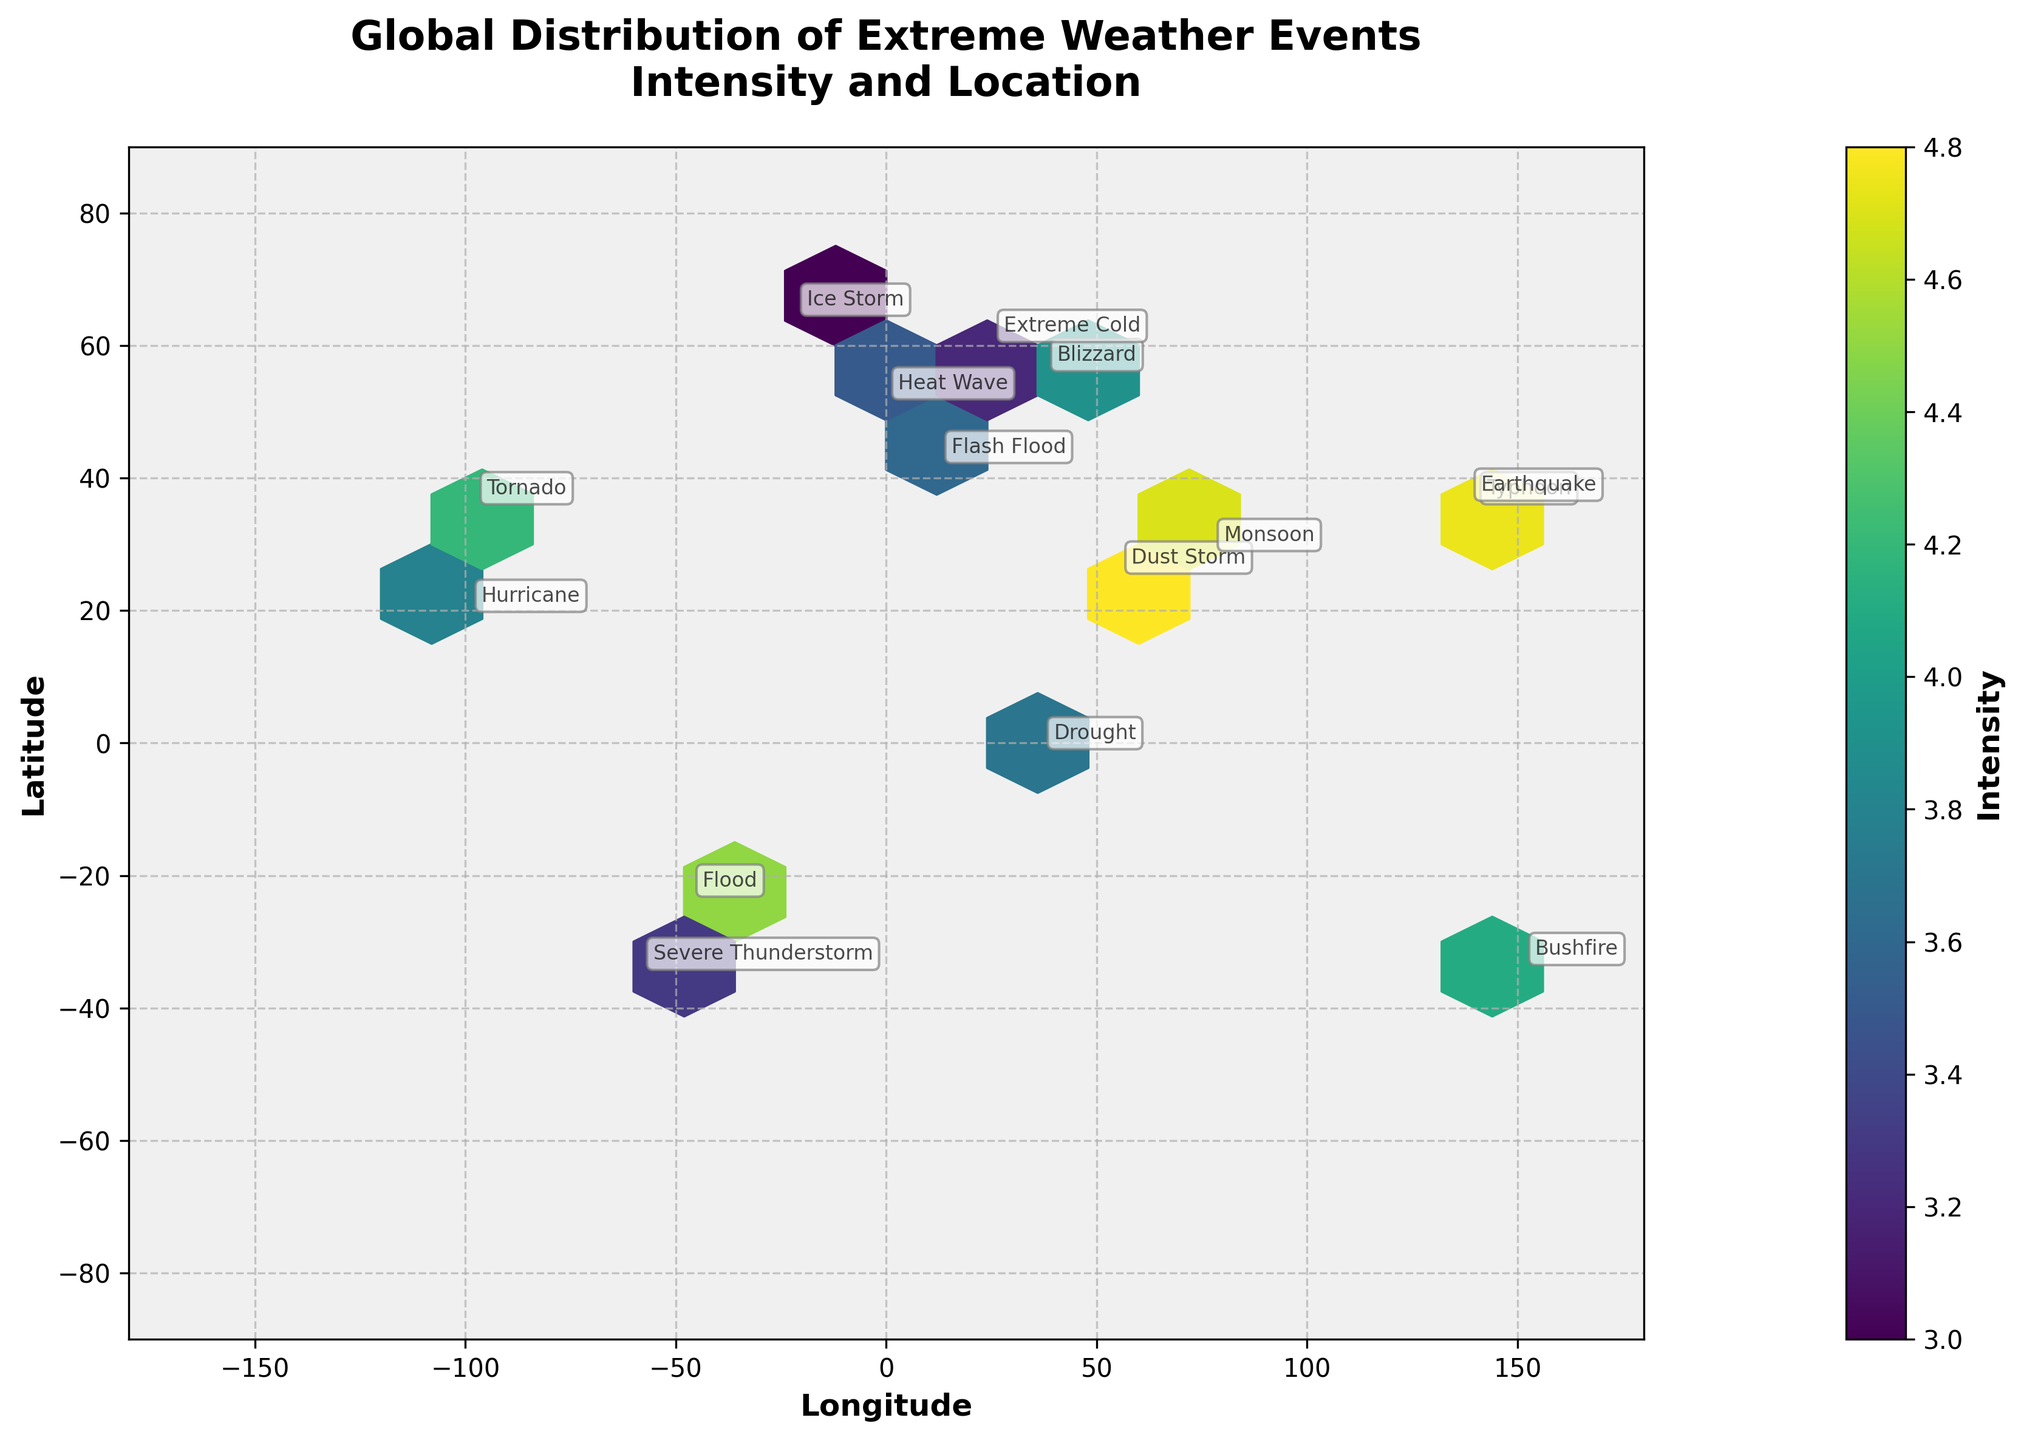What is the title of the figure? The title is displayed at the top center of the figure and is "Global Distribution of Extreme Weather Events\nIntensity and Location".
Answer: "Global Distribution of Extreme Weather Events\nIntensity and Location" What does the color intensity in the hexbin plot represent? The color intensity is explained by the color bar to the right of the plot, labeled "Intensity".
Answer: Intensity What is the range of longitudes shown in the figure? The x-axis, labeled "Longitude", ranges from -180 to 180.
Answer: -180 to 180 Which region shows the highest frequency of extreme weather events according to the annotations? By looking at the text annotations in the plot, South Asia has the highest frequency with an event frequency of 25 for Monsoon.
Answer: South Asia How many grid cells (hexagons) are displayed in the plot? The gridsize of 15 used in the plot generates a honeycomb-like pattern, and there are visibly 15 vertical and 15 horizontal grid cells.
Answer: 225 What are the latitudinal coordinates of the region with the extreme weather event labeled "Dust Storm"? Based on the annotation and coordinates in the figure, "Dust Storm" is located around latitude 25.2048.
Answer: 25.2048 Which region has the least intense extreme weather event according to the data? The Arctic region with an "Ice Storm" event has the lowest intensity of 3.0 shown by the color intensity within the plot.
Answer: Arctic Compare the intensity of extreme weather events between South America and Eastern Europe. Which is more intense? The annotations and hexbin colors show that South America (Flood, intensity 4.5) and Eastern Europe (Blizzard, intensity 3.9) have different intensities.
Answer: South America What is the average intensity of the three least frequent extreme weather events annotated in the figure? The least frequent events are in Northern Europe (7), Middle East (6), and Arctic (5), with intensities of 3.2, 4.8, and 3.0, respectively. The average is (3.2 + 4.8 + 3.0) / 3 = 3.67.
Answer: 3.67 What type of extreme weather event is labeled at longitude 138.2529 and latitude 36.2048? By referring to the annotations detailed in the figure, this location corresponds to an "Earthquake" in the Pacific Rim.
Answer: Earthquake 